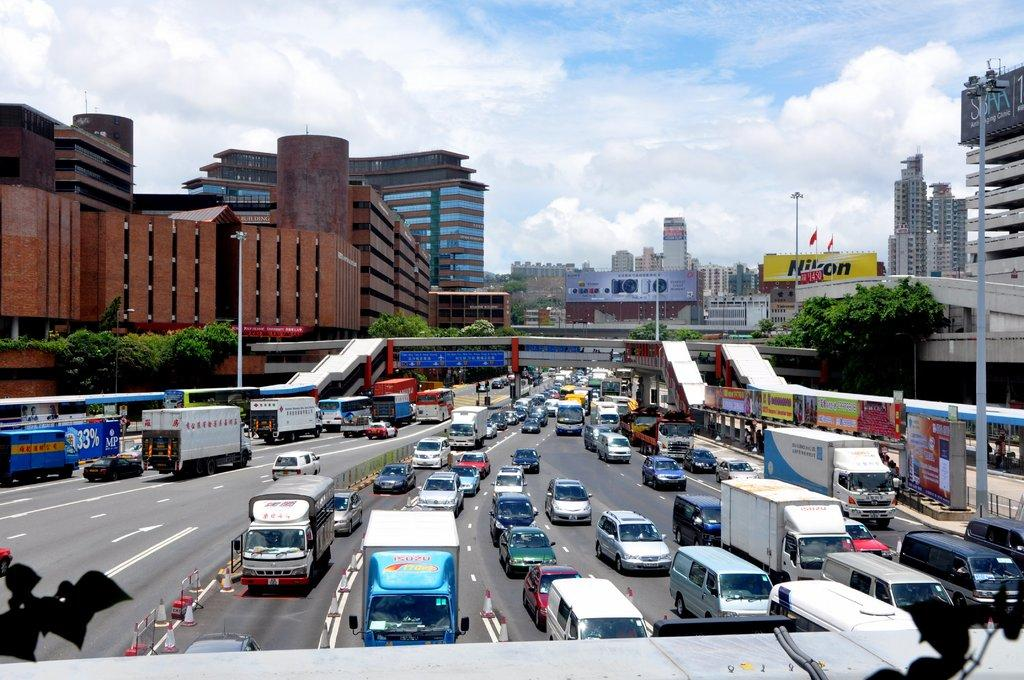What can be seen on the road in the image? There are vehicles on the road in the image. What objects are used to direct traffic in the image? Traffic cones are present in the image. What type of barrier is visible in the image? There is a fence in the image. What type of signage is visible in the image? Banners are visible in the image. What type of structure is present over the road in the image? There is a bridge in the image. What type of vegetation is present in the image? Trees are present in the image. What type of man-made structures are visible in the image? Buildings are visible in the image. What type of vertical structures are present in the image? Poles are present in the image. Can you describe the background of the image? The sky with clouds is visible in the background of the image. What type of lace can be seen hanging from the bridge in the image? There is no lace present in the image, and it is not hanging from the bridge. What type of fowl can be seen flying over the vehicles in the image? There is no fowl visible in the image. What type of border is present between the road and the sidewalk in the image? There is no specific border mentioned in the image; however, the presence of a fence and traffic cones may serve as a border between the road and the sidewalk. 